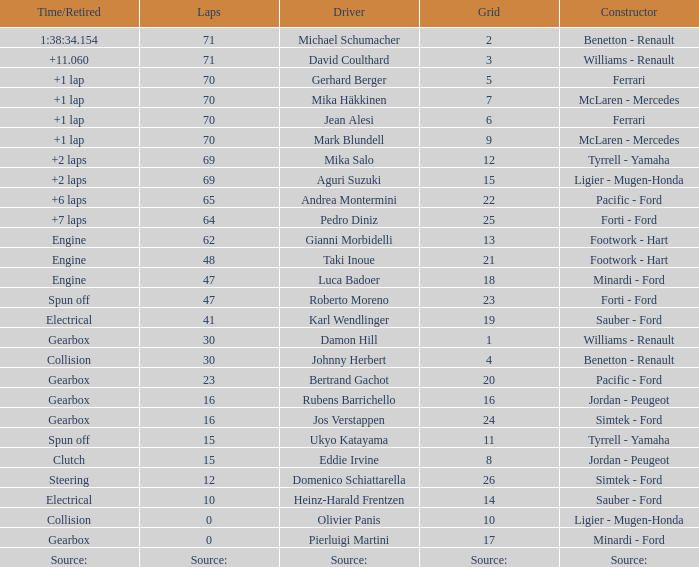David Coulthard was the driver in which grid? 3.0. 